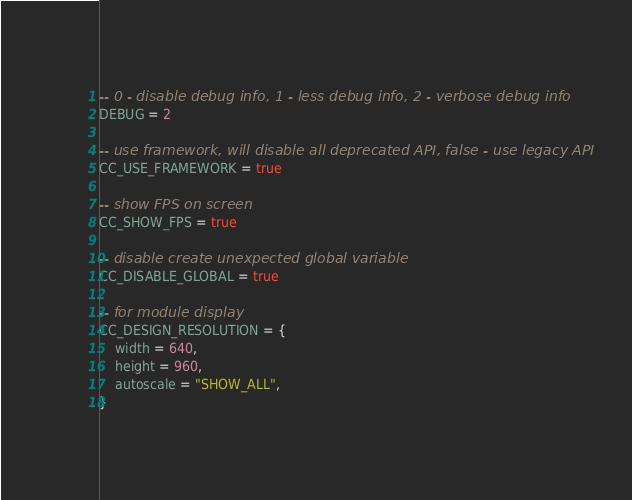Convert code to text. <code><loc_0><loc_0><loc_500><loc_500><_Lua_>
-- 0 - disable debug info, 1 - less debug info, 2 - verbose debug info
DEBUG = 2

-- use framework, will disable all deprecated API, false - use legacy API
CC_USE_FRAMEWORK = true

-- show FPS on screen
CC_SHOW_FPS = true

-- disable create unexpected global variable
CC_DISABLE_GLOBAL = true

-- for module display
CC_DESIGN_RESOLUTION = {
    width = 640,
    height = 960,
    autoscale = "SHOW_ALL",
}
</code> 